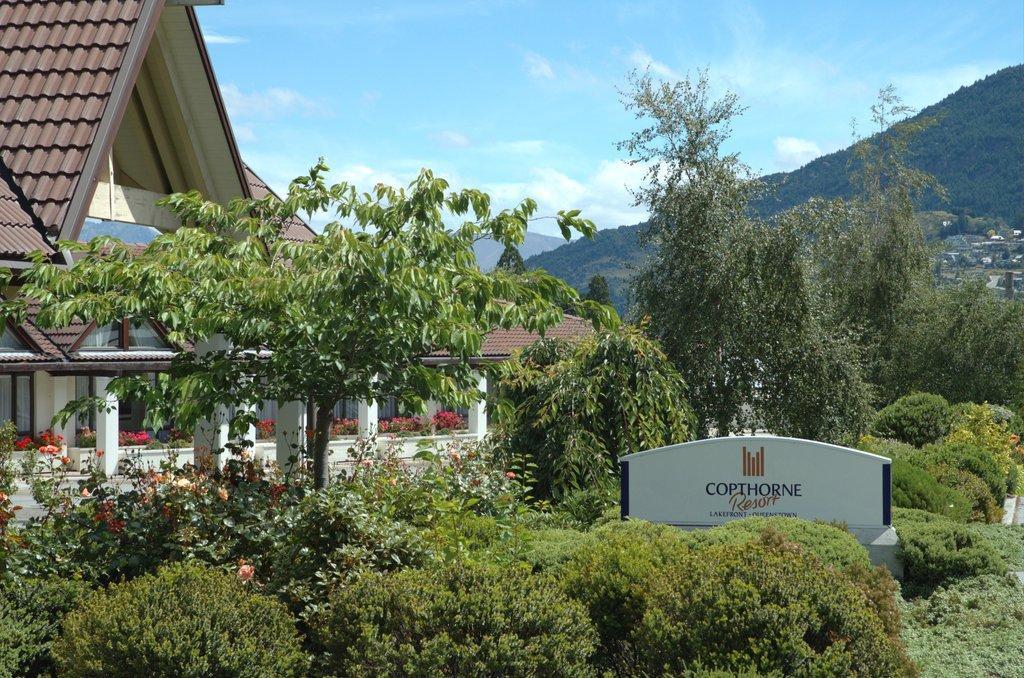How would you summarize this image in a sentence or two? As we can see in the image there are plants, trees, flowers, house, hills and at the top there is sky. 